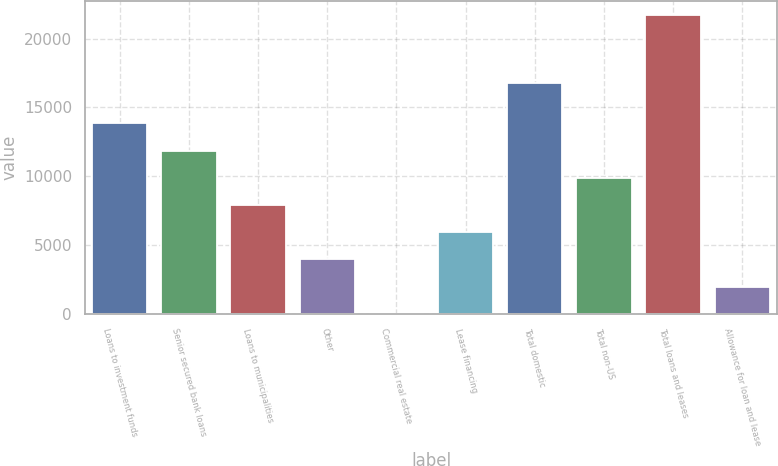<chart> <loc_0><loc_0><loc_500><loc_500><bar_chart><fcel>Loans to investment funds<fcel>Senior secured bank loans<fcel>Loans to municipalities<fcel>Other<fcel>Commercial real estate<fcel>Lease financing<fcel>Total domestic<fcel>Total non-US<fcel>Total loans and leases<fcel>Allowance for loan and lease<nl><fcel>13838<fcel>11865<fcel>7919<fcel>3973<fcel>27<fcel>5946<fcel>16777<fcel>9892<fcel>21677<fcel>2000<nl></chart> 